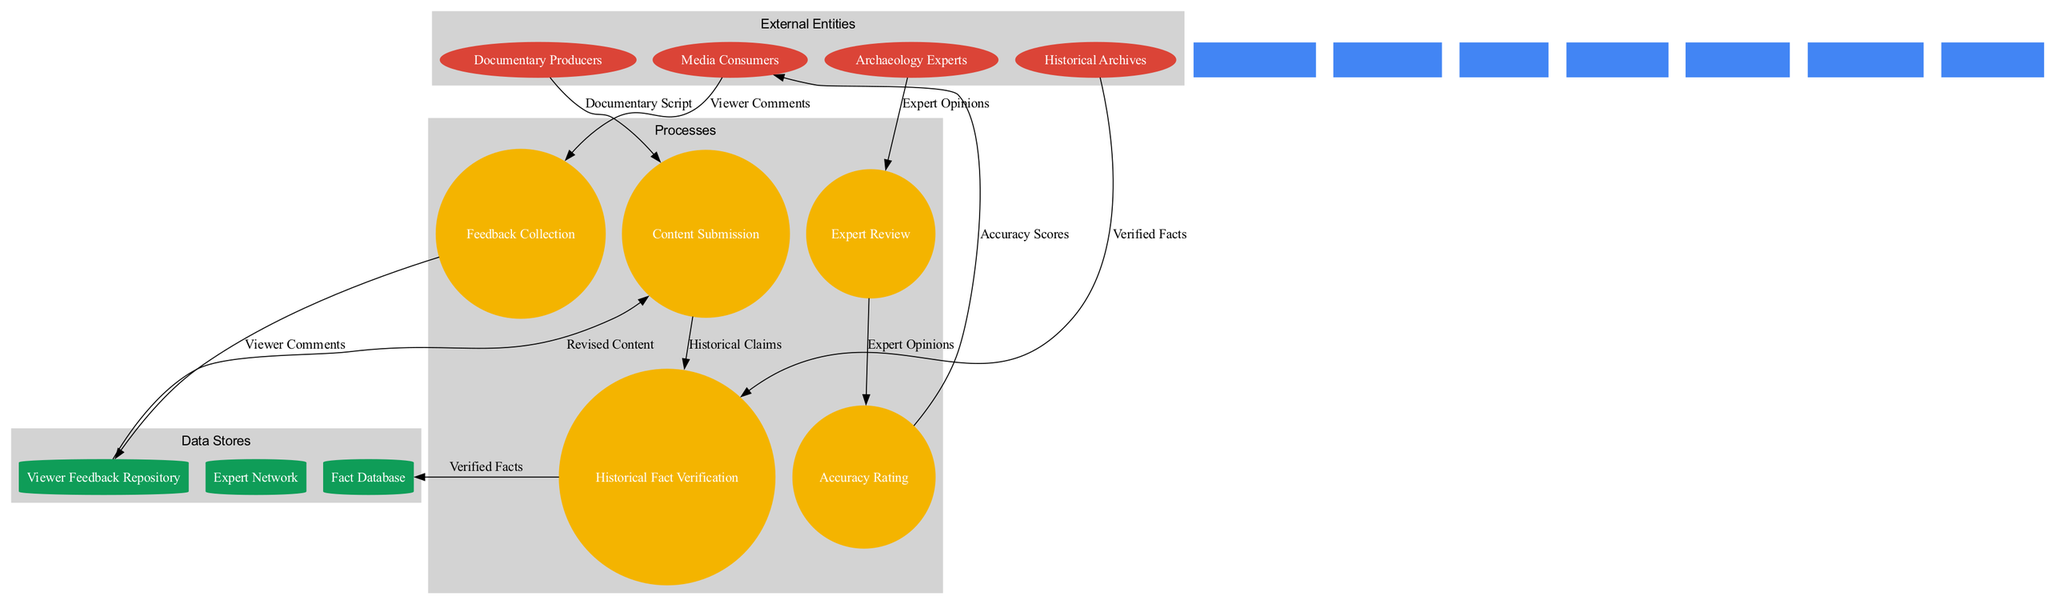What are the external entities in the diagram? The external entities are listed in the diagram under 'External Entities', which include Documentary Producers, Archaeology Experts, Historical Archives, and Media Consumers.
Answer: Documentary Producers, Archaeology Experts, Historical Archives, Media Consumers How many processes are defined in the diagram? The processes in the diagram are counted from the 'Processes' section. There are five processes: Content Submission, Historical Fact Verification, Expert Review, Accuracy Rating, and Feedback Collection.
Answer: 5 What does the 'Feedback Collection' process receive as input? The input to the 'Feedback Collection' process comes from the 'Media Consumers', which is indicated by the arrow connecting them. The input is the 'Viewer Comments'.
Answer: Viewer Comments Which data store is associated with the 'Expert Review' process? Following the data flow, the 'Expert Review' process outputs 'Expert Opinions' which aligns with the process flow where 'Expert Opinions' connect to 'Accuracy Rating', indicating connection but not directly to any data store. However, the 'Expert Network' serves experts and indirectly indicates a relationship there.
Answer: Expert Network What is the final output of the 'Accuracy Rating' process? The output of the 'Accuracy Rating' process is 'Accuracy Scores', as defined by the arrow leading from 'Accuracy Rating' to the next entity in the flow, which can also corresponds to 'Media Consumers'.
Answer: Accuracy Scores Which process receives inputs from both 'Historical Archives' and 'Documentary Producers'? The 'Historical Fact Verification' process receives inputs from both sources, as depicted in the diagram with arrows pointing into it from 'Historical Archives' and 'Documentary Producers'.
Answer: Historical Fact Verification What is the purpose of the 'Viewer Feedback Repository'? The 'Viewer Feedback Repository' holds 'Viewer Comments', which are collected from the 'Feedback Collection' process. This indicates its purpose as a storage system for viewer inputs.
Answer: Store Viewer Comments Which external entity interacts with the 'Content Submission' process? The 'Documentary Producers' interact with the 'Content Submission' process, as indicated by the arrow directed towards 'Content Submission' from 'Documentary Producers'.
Answer: Documentary Producers How are 'Verified Facts' utilized in the diagram? 'Verified Facts' are first outputted from the 'Historical Fact Verification' process and are then directed into the 'Fact Database', indicating their role as important data for factual evidence.
Answer: Fact Database What data flow connects to 'Revised Content'? The data flow that connects to 'Revised Content' comes from 'Viewer Feedback Repository', indicating that the revised content is created based on feedback collected from viewers.
Answer: Viewer Feedback Repository 